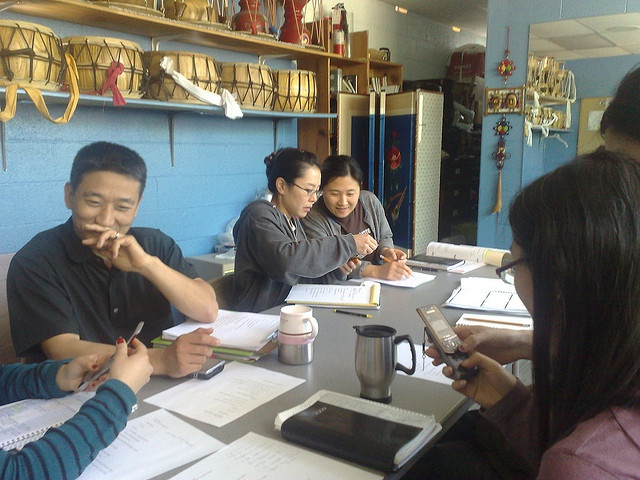Describe the objects in this image and their specific colors. I can see people in gray, black, and maroon tones, people in gray, black, and tan tones, people in gray, black, and darkgray tones, people in gray, blue, navy, and teal tones, and book in gray, black, and darkgray tones in this image. 